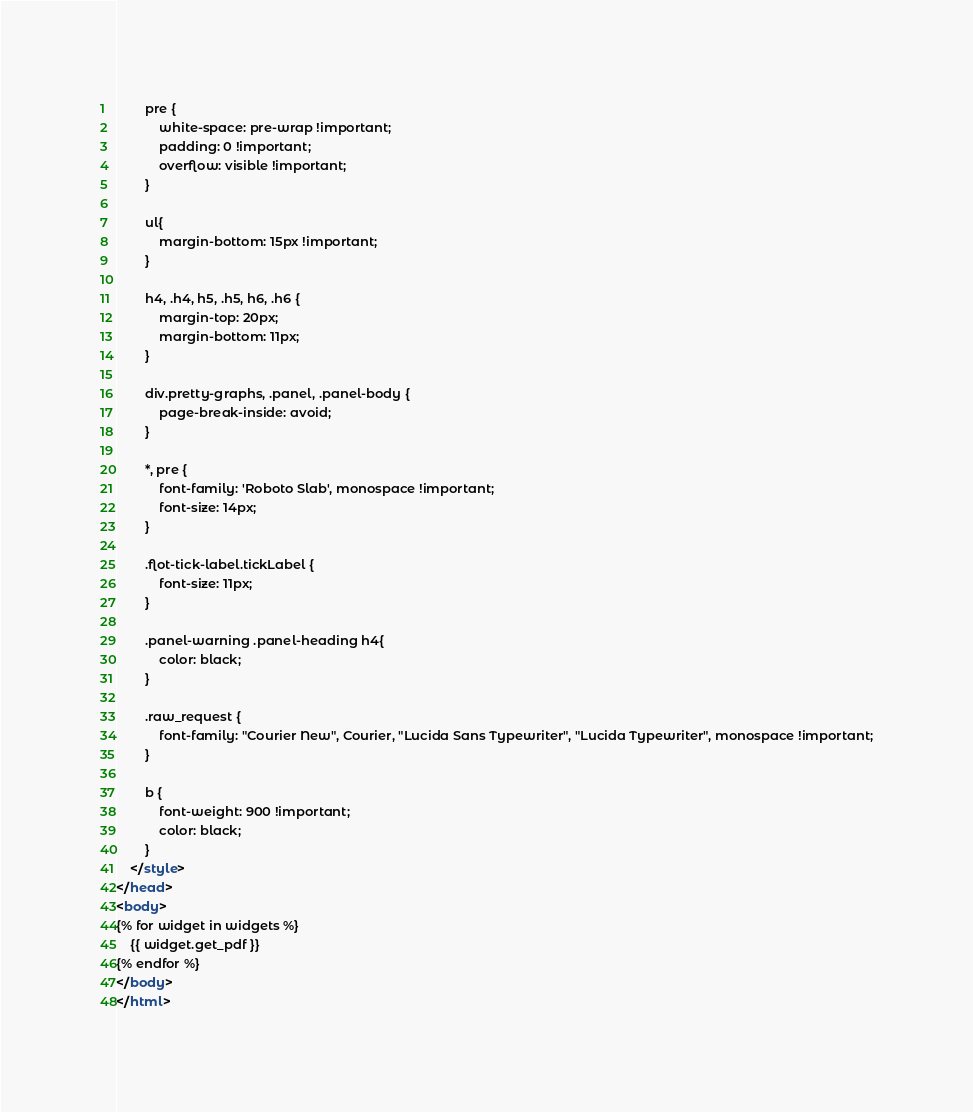Convert code to text. <code><loc_0><loc_0><loc_500><loc_500><_HTML_>
        pre {
            white-space: pre-wrap !important;
            padding: 0 !important;
            overflow: visible !important;
        }

        ul{
            margin-bottom: 15px !important;
        }

        h4, .h4, h5, .h5, h6, .h6 {
            margin-top: 20px;
            margin-bottom: 11px;
        }

        div.pretty-graphs, .panel, .panel-body {
            page-break-inside: avoid;
        }

        *, pre {
            font-family: 'Roboto Slab', monospace !important;
            font-size: 14px;
        }

        .flot-tick-label.tickLabel {
            font-size: 11px;
        }

        .panel-warning .panel-heading h4{
            color: black;
        }

        .raw_request {
            font-family: "Courier New", Courier, "Lucida Sans Typewriter", "Lucida Typewriter", monospace !important;
        }

        b {
            font-weight: 900 !important;
            color: black;
        }
    </style>
</head>
<body>
{% for widget in widgets %}
    {{ widget.get_pdf }}
{% endfor %}
</body>
</html>
</code> 